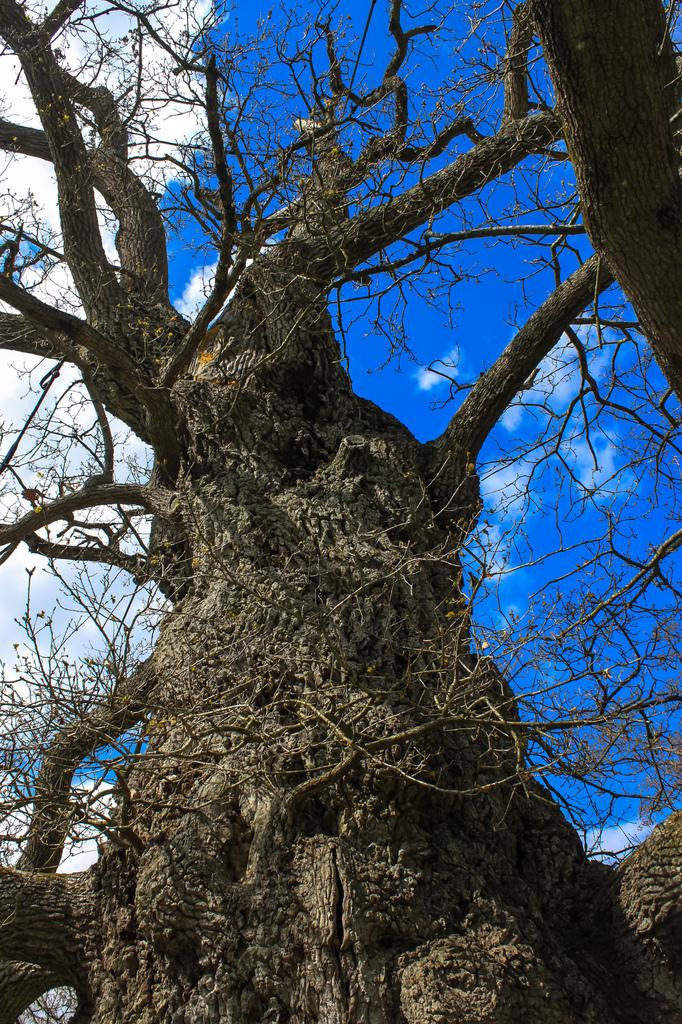What is located in the front of the image? There is a tree in the front of the image. What is visible in the background of the image? The sky is visible in the background of the image. What can be seen in the sky in the image? Clouds are present in the background of the image. What type of veil can be seen covering the tree in the image? There is no veil present in the image; the tree is not covered. What type of road can be seen passing through the image? There is no road present in the image; it only features a tree and the sky. 